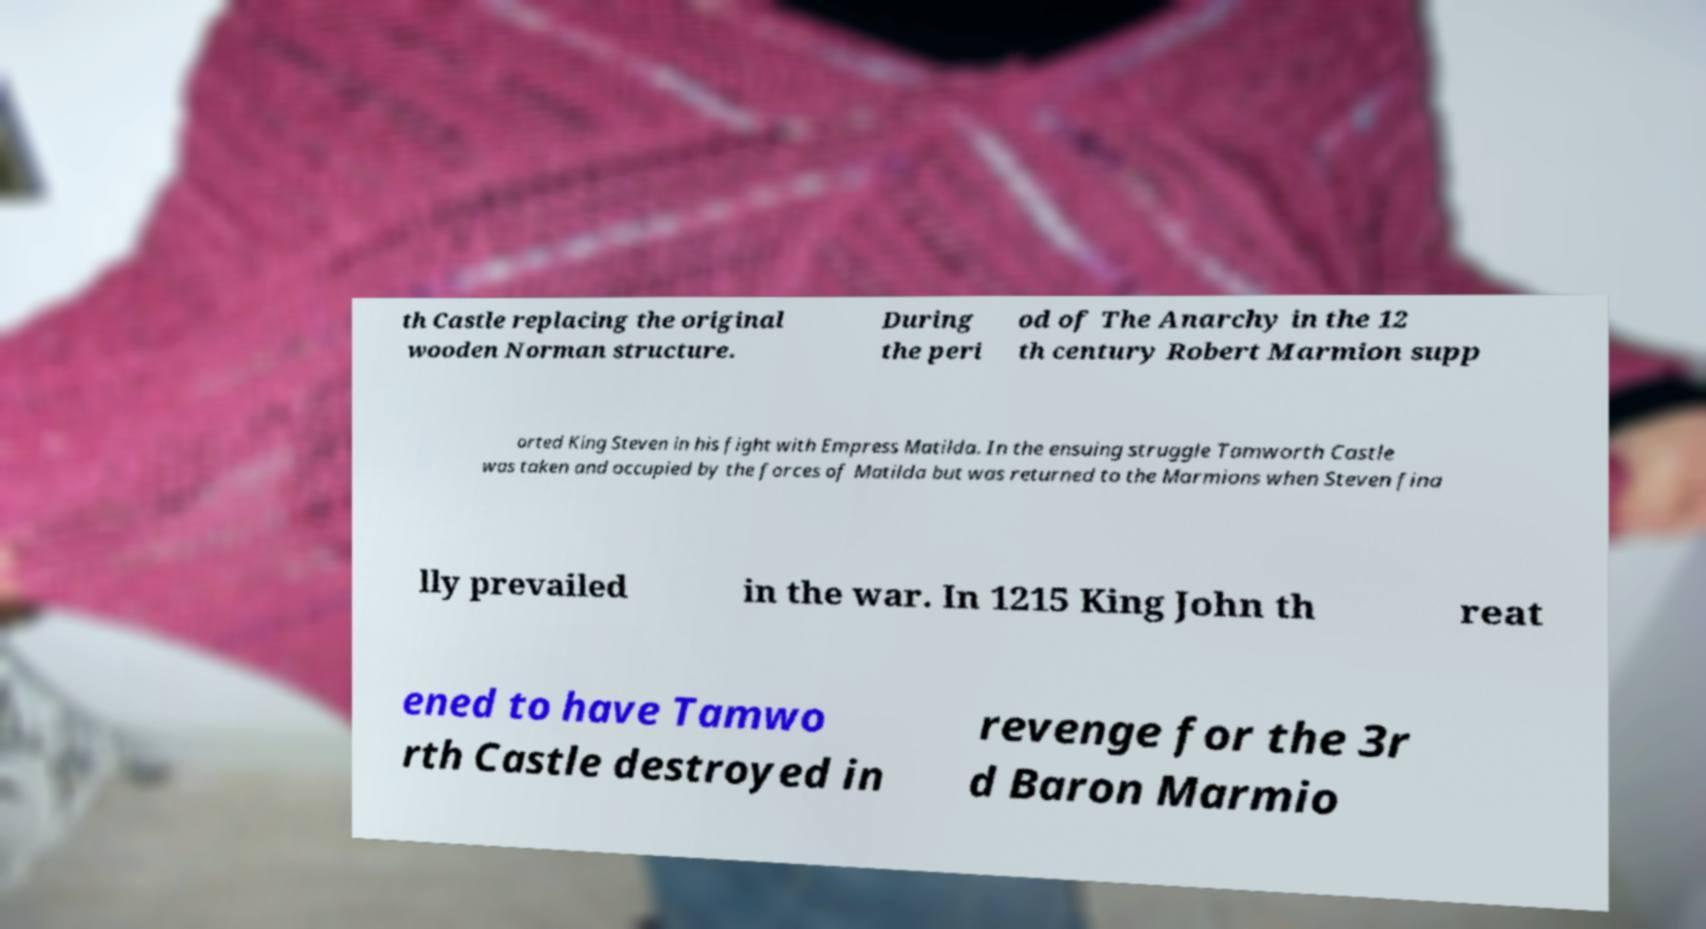I need the written content from this picture converted into text. Can you do that? th Castle replacing the original wooden Norman structure. During the peri od of The Anarchy in the 12 th century Robert Marmion supp orted King Steven in his fight with Empress Matilda. In the ensuing struggle Tamworth Castle was taken and occupied by the forces of Matilda but was returned to the Marmions when Steven fina lly prevailed in the war. In 1215 King John th reat ened to have Tamwo rth Castle destroyed in revenge for the 3r d Baron Marmio 